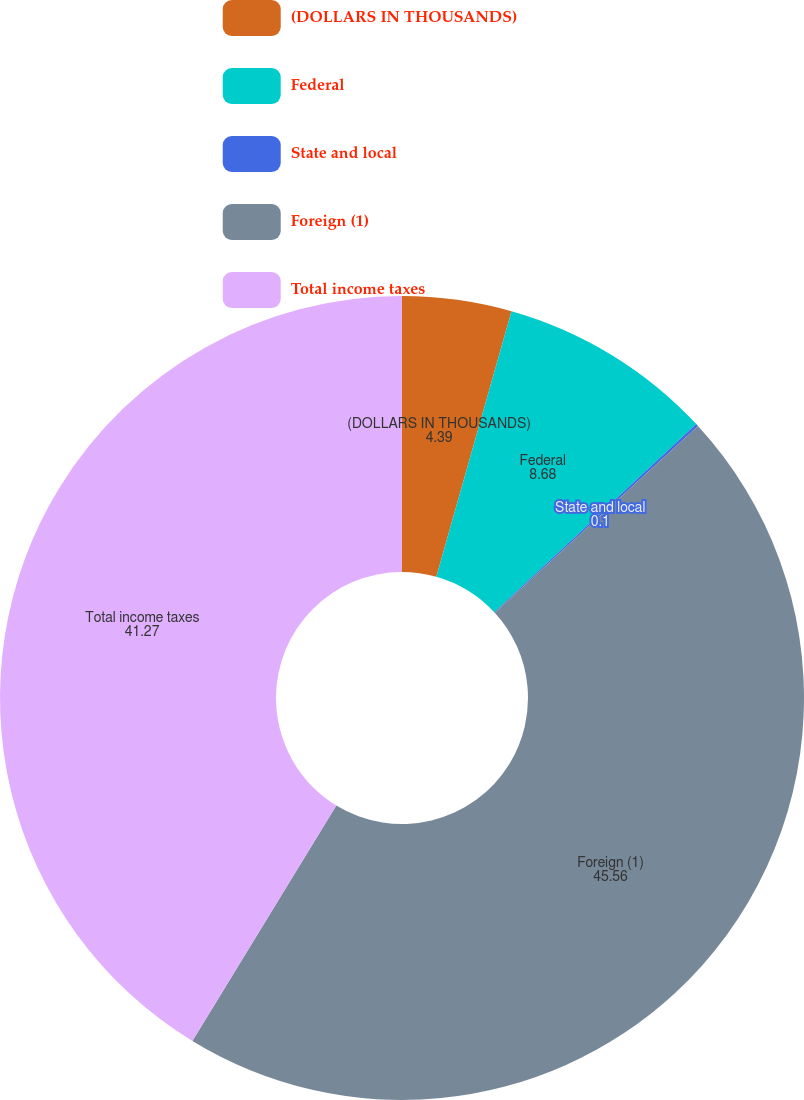Convert chart to OTSL. <chart><loc_0><loc_0><loc_500><loc_500><pie_chart><fcel>(DOLLARS IN THOUSANDS)<fcel>Federal<fcel>State and local<fcel>Foreign (1)<fcel>Total income taxes<nl><fcel>4.39%<fcel>8.68%<fcel>0.1%<fcel>45.56%<fcel>41.27%<nl></chart> 